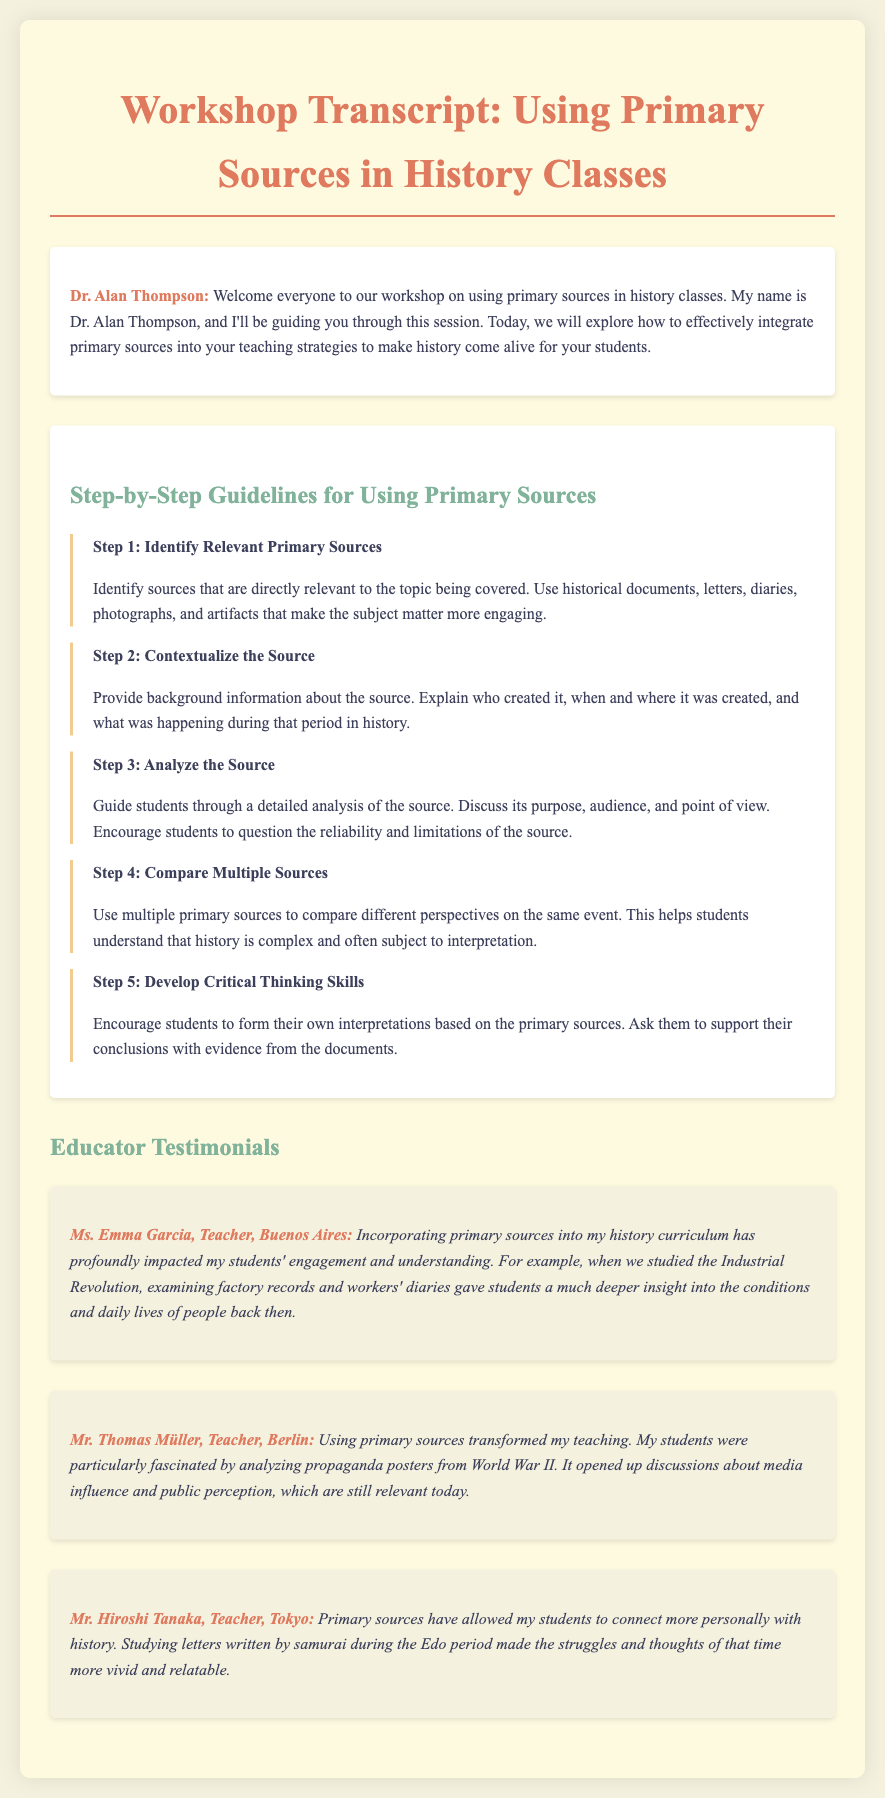What is the workshop title? The title of the workshop is presented at the beginning of the document.
Answer: Using Primary Sources in History Classes Who is the speaker guiding the session? The name of the speaker, who is guiding the workshop, is mentioned in the introduction.
Answer: Dr. Alan Thompson What is the first step in the guidelines? The first step is detailed in the step-by-step section.
Answer: Identify Relevant Primary Sources What does Step 3 focus on? The third step focuses on a specific aspect of interaction with primary sources.
Answer: Analyze the Source Which city does Ms. Emma Garcia teach in? The location of Ms. Emma Garcia, one of the educators providing a testimonial, is specified in her statement.
Answer: Buenos Aires What year is primarily discussed in Mr. Thomas Müller's testimonial? The testimonial from Mr. Thomas Müller refers to events from a specific historical context.
Answer: World War II How do primary sources impact student engagement according to Ms. Emma Garcia? The impact of primary sources on engagement is expressed in her testimonial.
Answer: Profoundly What kind of documents did Mr. Hiroshi Tanaka's students study? He specifies a unique type of primary source that his students engaged with.
Answer: Letters written by samurai 